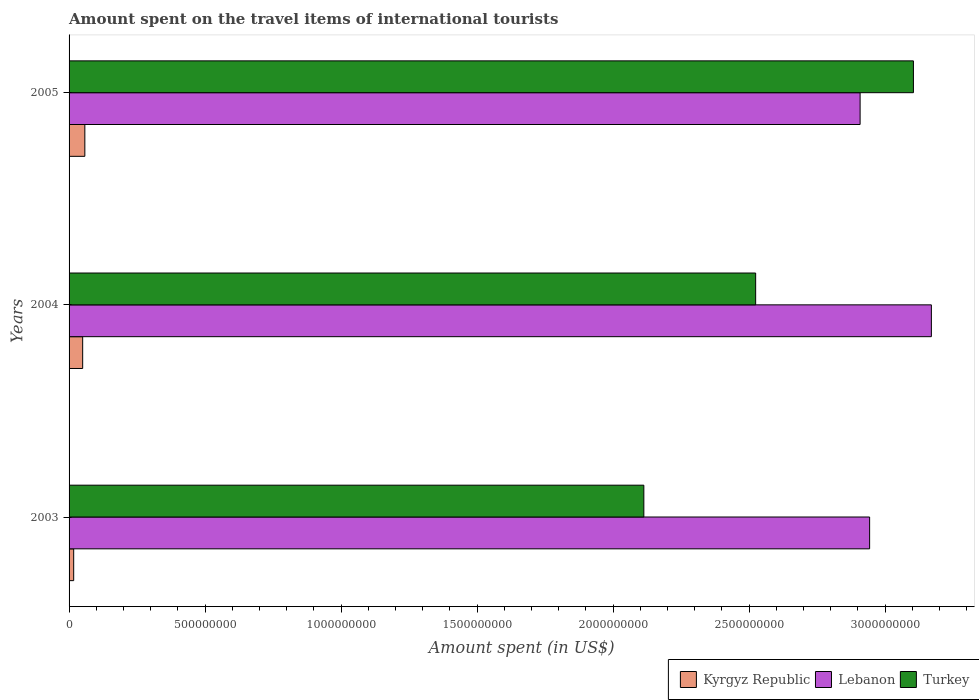How many different coloured bars are there?
Offer a terse response. 3. How many groups of bars are there?
Offer a very short reply. 3. Are the number of bars on each tick of the Y-axis equal?
Give a very brief answer. Yes. How many bars are there on the 1st tick from the top?
Provide a short and direct response. 3. How many bars are there on the 1st tick from the bottom?
Keep it short and to the point. 3. In how many cases, is the number of bars for a given year not equal to the number of legend labels?
Make the answer very short. 0. What is the amount spent on the travel items of international tourists in Lebanon in 2004?
Your response must be concise. 3.17e+09. Across all years, what is the maximum amount spent on the travel items of international tourists in Lebanon?
Make the answer very short. 3.17e+09. Across all years, what is the minimum amount spent on the travel items of international tourists in Kyrgyz Republic?
Your answer should be very brief. 1.70e+07. In which year was the amount spent on the travel items of international tourists in Lebanon minimum?
Ensure brevity in your answer.  2005. What is the total amount spent on the travel items of international tourists in Lebanon in the graph?
Provide a short and direct response. 9.02e+09. What is the difference between the amount spent on the travel items of international tourists in Kyrgyz Republic in 2003 and that in 2004?
Provide a short and direct response. -3.30e+07. What is the difference between the amount spent on the travel items of international tourists in Kyrgyz Republic in 2004 and the amount spent on the travel items of international tourists in Lebanon in 2003?
Provide a short and direct response. -2.89e+09. What is the average amount spent on the travel items of international tourists in Kyrgyz Republic per year?
Offer a very short reply. 4.17e+07. In the year 2004, what is the difference between the amount spent on the travel items of international tourists in Kyrgyz Republic and amount spent on the travel items of international tourists in Turkey?
Provide a short and direct response. -2.47e+09. In how many years, is the amount spent on the travel items of international tourists in Lebanon greater than 2300000000 US$?
Keep it short and to the point. 3. What is the ratio of the amount spent on the travel items of international tourists in Turkey in 2003 to that in 2004?
Make the answer very short. 0.84. What is the difference between the highest and the second highest amount spent on the travel items of international tourists in Kyrgyz Republic?
Your answer should be very brief. 8.00e+06. What is the difference between the highest and the lowest amount spent on the travel items of international tourists in Kyrgyz Republic?
Give a very brief answer. 4.10e+07. Is the sum of the amount spent on the travel items of international tourists in Turkey in 2003 and 2005 greater than the maximum amount spent on the travel items of international tourists in Kyrgyz Republic across all years?
Keep it short and to the point. Yes. What does the 2nd bar from the top in 2005 represents?
Your answer should be very brief. Lebanon. How many bars are there?
Your answer should be compact. 9. Are all the bars in the graph horizontal?
Your response must be concise. Yes. What is the difference between two consecutive major ticks on the X-axis?
Ensure brevity in your answer.  5.00e+08. Does the graph contain grids?
Provide a short and direct response. No. What is the title of the graph?
Keep it short and to the point. Amount spent on the travel items of international tourists. Does "Belarus" appear as one of the legend labels in the graph?
Keep it short and to the point. No. What is the label or title of the X-axis?
Give a very brief answer. Amount spent (in US$). What is the Amount spent (in US$) in Kyrgyz Republic in 2003?
Keep it short and to the point. 1.70e+07. What is the Amount spent (in US$) in Lebanon in 2003?
Your answer should be very brief. 2.94e+09. What is the Amount spent (in US$) in Turkey in 2003?
Make the answer very short. 2.11e+09. What is the Amount spent (in US$) in Kyrgyz Republic in 2004?
Your answer should be very brief. 5.00e+07. What is the Amount spent (in US$) of Lebanon in 2004?
Offer a terse response. 3.17e+09. What is the Amount spent (in US$) of Turkey in 2004?
Give a very brief answer. 2.52e+09. What is the Amount spent (in US$) in Kyrgyz Republic in 2005?
Your answer should be compact. 5.80e+07. What is the Amount spent (in US$) in Lebanon in 2005?
Keep it short and to the point. 2.91e+09. What is the Amount spent (in US$) of Turkey in 2005?
Your answer should be very brief. 3.10e+09. Across all years, what is the maximum Amount spent (in US$) in Kyrgyz Republic?
Your answer should be very brief. 5.80e+07. Across all years, what is the maximum Amount spent (in US$) in Lebanon?
Give a very brief answer. 3.17e+09. Across all years, what is the maximum Amount spent (in US$) in Turkey?
Offer a terse response. 3.10e+09. Across all years, what is the minimum Amount spent (in US$) of Kyrgyz Republic?
Offer a terse response. 1.70e+07. Across all years, what is the minimum Amount spent (in US$) in Lebanon?
Ensure brevity in your answer.  2.91e+09. Across all years, what is the minimum Amount spent (in US$) in Turkey?
Provide a succinct answer. 2.11e+09. What is the total Amount spent (in US$) of Kyrgyz Republic in the graph?
Keep it short and to the point. 1.25e+08. What is the total Amount spent (in US$) in Lebanon in the graph?
Give a very brief answer. 9.02e+09. What is the total Amount spent (in US$) in Turkey in the graph?
Make the answer very short. 7.74e+09. What is the difference between the Amount spent (in US$) in Kyrgyz Republic in 2003 and that in 2004?
Your answer should be compact. -3.30e+07. What is the difference between the Amount spent (in US$) in Lebanon in 2003 and that in 2004?
Your answer should be very brief. -2.27e+08. What is the difference between the Amount spent (in US$) in Turkey in 2003 and that in 2004?
Your response must be concise. -4.11e+08. What is the difference between the Amount spent (in US$) in Kyrgyz Republic in 2003 and that in 2005?
Your answer should be very brief. -4.10e+07. What is the difference between the Amount spent (in US$) in Lebanon in 2003 and that in 2005?
Ensure brevity in your answer.  3.50e+07. What is the difference between the Amount spent (in US$) in Turkey in 2003 and that in 2005?
Your answer should be very brief. -9.91e+08. What is the difference between the Amount spent (in US$) of Kyrgyz Republic in 2004 and that in 2005?
Provide a succinct answer. -8.00e+06. What is the difference between the Amount spent (in US$) of Lebanon in 2004 and that in 2005?
Provide a succinct answer. 2.62e+08. What is the difference between the Amount spent (in US$) of Turkey in 2004 and that in 2005?
Keep it short and to the point. -5.80e+08. What is the difference between the Amount spent (in US$) of Kyrgyz Republic in 2003 and the Amount spent (in US$) of Lebanon in 2004?
Provide a succinct answer. -3.15e+09. What is the difference between the Amount spent (in US$) of Kyrgyz Republic in 2003 and the Amount spent (in US$) of Turkey in 2004?
Your response must be concise. -2.51e+09. What is the difference between the Amount spent (in US$) in Lebanon in 2003 and the Amount spent (in US$) in Turkey in 2004?
Offer a very short reply. 4.19e+08. What is the difference between the Amount spent (in US$) of Kyrgyz Republic in 2003 and the Amount spent (in US$) of Lebanon in 2005?
Give a very brief answer. -2.89e+09. What is the difference between the Amount spent (in US$) in Kyrgyz Republic in 2003 and the Amount spent (in US$) in Turkey in 2005?
Provide a succinct answer. -3.09e+09. What is the difference between the Amount spent (in US$) of Lebanon in 2003 and the Amount spent (in US$) of Turkey in 2005?
Give a very brief answer. -1.61e+08. What is the difference between the Amount spent (in US$) of Kyrgyz Republic in 2004 and the Amount spent (in US$) of Lebanon in 2005?
Your answer should be compact. -2.86e+09. What is the difference between the Amount spent (in US$) in Kyrgyz Republic in 2004 and the Amount spent (in US$) in Turkey in 2005?
Make the answer very short. -3.05e+09. What is the difference between the Amount spent (in US$) in Lebanon in 2004 and the Amount spent (in US$) in Turkey in 2005?
Your response must be concise. 6.60e+07. What is the average Amount spent (in US$) in Kyrgyz Republic per year?
Make the answer very short. 4.17e+07. What is the average Amount spent (in US$) in Lebanon per year?
Provide a succinct answer. 3.01e+09. What is the average Amount spent (in US$) of Turkey per year?
Make the answer very short. 2.58e+09. In the year 2003, what is the difference between the Amount spent (in US$) of Kyrgyz Republic and Amount spent (in US$) of Lebanon?
Your answer should be compact. -2.93e+09. In the year 2003, what is the difference between the Amount spent (in US$) in Kyrgyz Republic and Amount spent (in US$) in Turkey?
Keep it short and to the point. -2.10e+09. In the year 2003, what is the difference between the Amount spent (in US$) in Lebanon and Amount spent (in US$) in Turkey?
Keep it short and to the point. 8.30e+08. In the year 2004, what is the difference between the Amount spent (in US$) of Kyrgyz Republic and Amount spent (in US$) of Lebanon?
Your response must be concise. -3.12e+09. In the year 2004, what is the difference between the Amount spent (in US$) of Kyrgyz Republic and Amount spent (in US$) of Turkey?
Provide a succinct answer. -2.47e+09. In the year 2004, what is the difference between the Amount spent (in US$) of Lebanon and Amount spent (in US$) of Turkey?
Ensure brevity in your answer.  6.46e+08. In the year 2005, what is the difference between the Amount spent (in US$) in Kyrgyz Republic and Amount spent (in US$) in Lebanon?
Offer a terse response. -2.85e+09. In the year 2005, what is the difference between the Amount spent (in US$) of Kyrgyz Republic and Amount spent (in US$) of Turkey?
Give a very brief answer. -3.05e+09. In the year 2005, what is the difference between the Amount spent (in US$) of Lebanon and Amount spent (in US$) of Turkey?
Your answer should be very brief. -1.96e+08. What is the ratio of the Amount spent (in US$) in Kyrgyz Republic in 2003 to that in 2004?
Your answer should be very brief. 0.34. What is the ratio of the Amount spent (in US$) in Lebanon in 2003 to that in 2004?
Your answer should be very brief. 0.93. What is the ratio of the Amount spent (in US$) in Turkey in 2003 to that in 2004?
Ensure brevity in your answer.  0.84. What is the ratio of the Amount spent (in US$) of Kyrgyz Republic in 2003 to that in 2005?
Provide a short and direct response. 0.29. What is the ratio of the Amount spent (in US$) of Lebanon in 2003 to that in 2005?
Give a very brief answer. 1.01. What is the ratio of the Amount spent (in US$) of Turkey in 2003 to that in 2005?
Provide a succinct answer. 0.68. What is the ratio of the Amount spent (in US$) of Kyrgyz Republic in 2004 to that in 2005?
Make the answer very short. 0.86. What is the ratio of the Amount spent (in US$) in Lebanon in 2004 to that in 2005?
Offer a terse response. 1.09. What is the ratio of the Amount spent (in US$) in Turkey in 2004 to that in 2005?
Offer a terse response. 0.81. What is the difference between the highest and the second highest Amount spent (in US$) in Kyrgyz Republic?
Offer a very short reply. 8.00e+06. What is the difference between the highest and the second highest Amount spent (in US$) in Lebanon?
Ensure brevity in your answer.  2.27e+08. What is the difference between the highest and the second highest Amount spent (in US$) of Turkey?
Make the answer very short. 5.80e+08. What is the difference between the highest and the lowest Amount spent (in US$) in Kyrgyz Republic?
Keep it short and to the point. 4.10e+07. What is the difference between the highest and the lowest Amount spent (in US$) of Lebanon?
Provide a short and direct response. 2.62e+08. What is the difference between the highest and the lowest Amount spent (in US$) in Turkey?
Offer a terse response. 9.91e+08. 